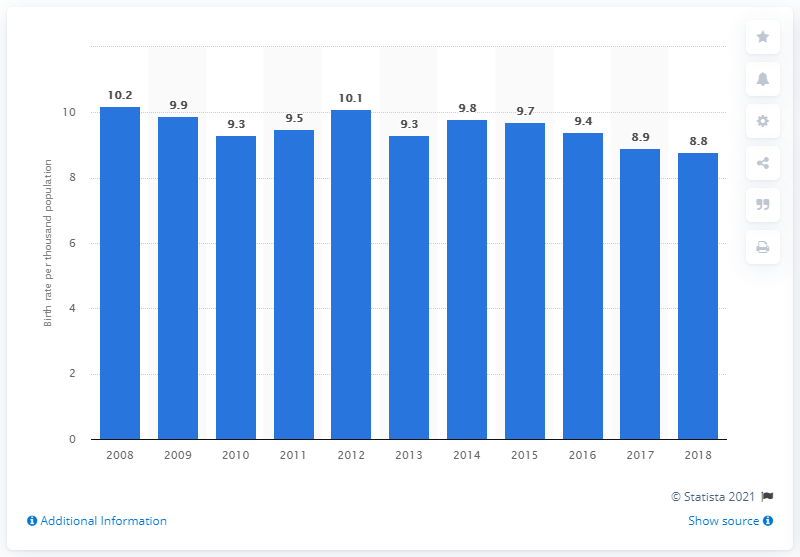Highlight a few significant elements in this photo. In 2018, the crude birth rate in Singapore was 8.8 per 1,000 people. 